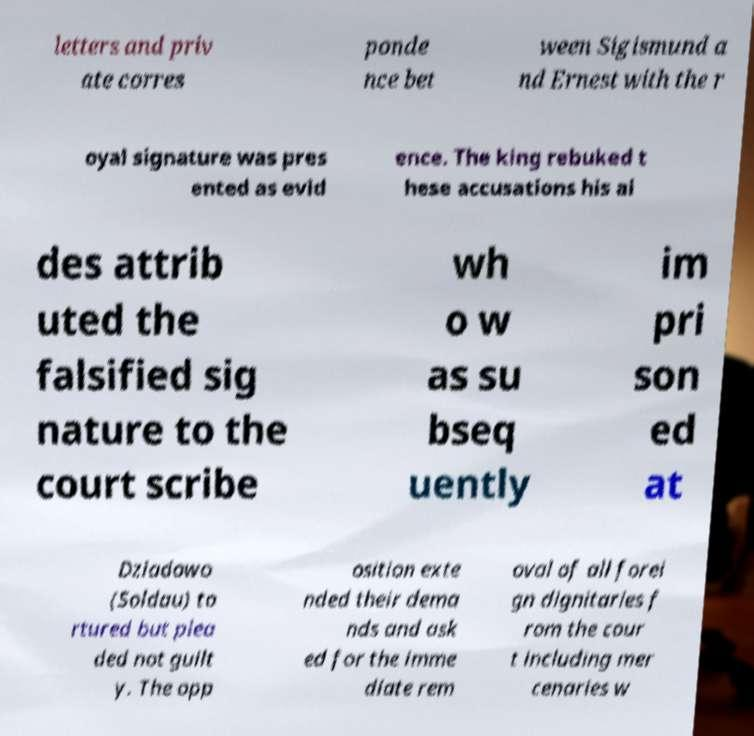Please read and relay the text visible in this image. What does it say? letters and priv ate corres ponde nce bet ween Sigismund a nd Ernest with the r oyal signature was pres ented as evid ence. The king rebuked t hese accusations his ai des attrib uted the falsified sig nature to the court scribe wh o w as su bseq uently im pri son ed at Dziadowo (Soldau) to rtured but plea ded not guilt y. The opp osition exte nded their dema nds and ask ed for the imme diate rem oval of all forei gn dignitaries f rom the cour t including mer cenaries w 